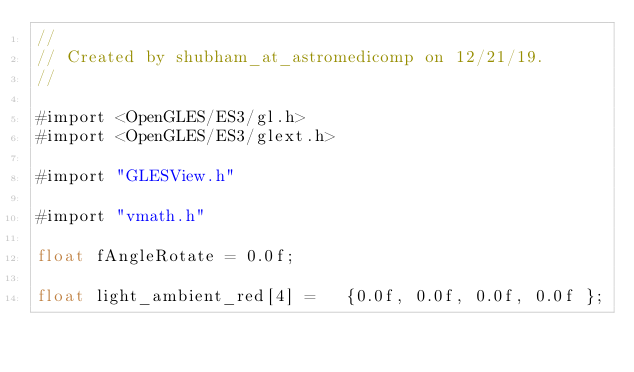Convert code to text. <code><loc_0><loc_0><loc_500><loc_500><_ObjectiveC_>//
// Created by shubham_at_astromedicomp on 12/21/19.
//

#import <OpenGLES/ES3/gl.h>
#import <OpenGLES/ES3/glext.h>

#import "GLESView.h"

#import "vmath.h"

float fAngleRotate = 0.0f;

float light_ambient_red[4] =   {0.0f, 0.0f, 0.0f, 0.0f };</code> 